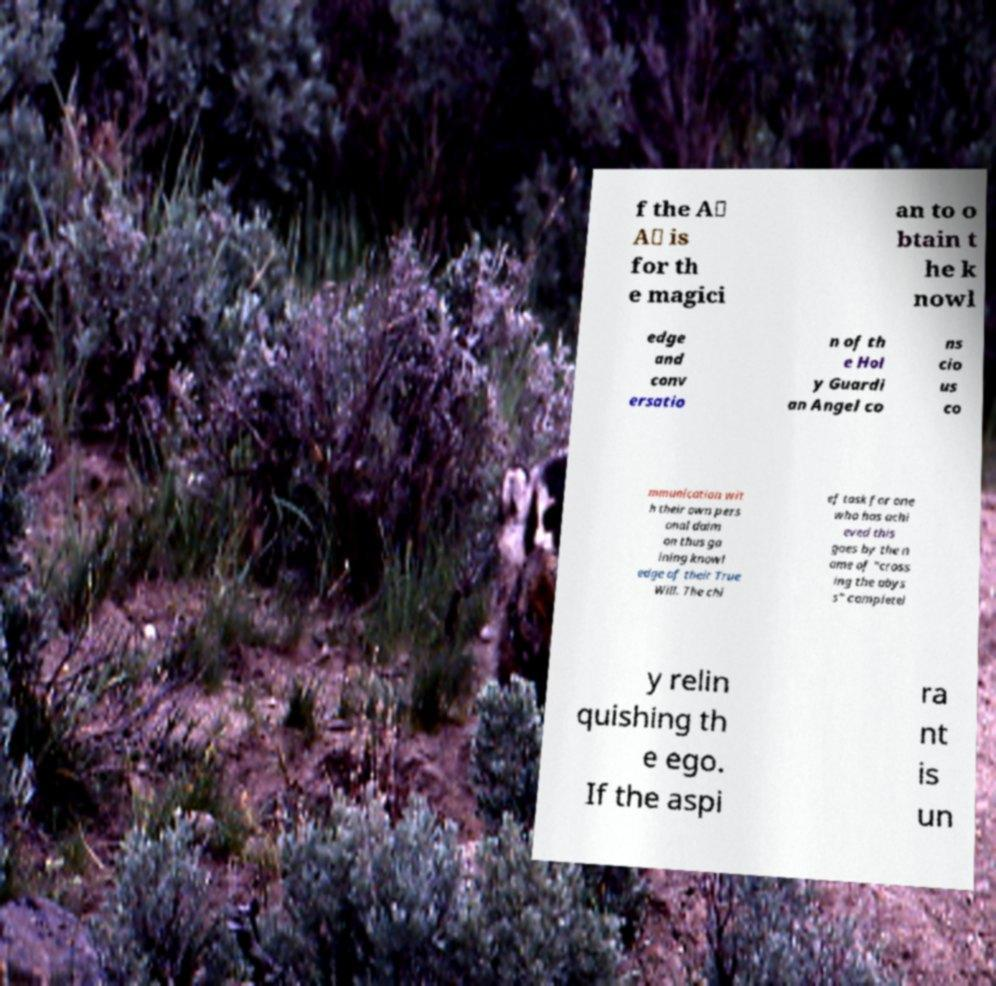Could you assist in decoding the text presented in this image and type it out clearly? f the A∴ A∴ is for th e magici an to o btain t he k nowl edge and conv ersatio n of th e Hol y Guardi an Angel co ns cio us co mmunication wit h their own pers onal daim on thus ga ining knowl edge of their True Will. The chi ef task for one who has achi eved this goes by the n ame of "cross ing the abys s" completel y relin quishing th e ego. If the aspi ra nt is un 